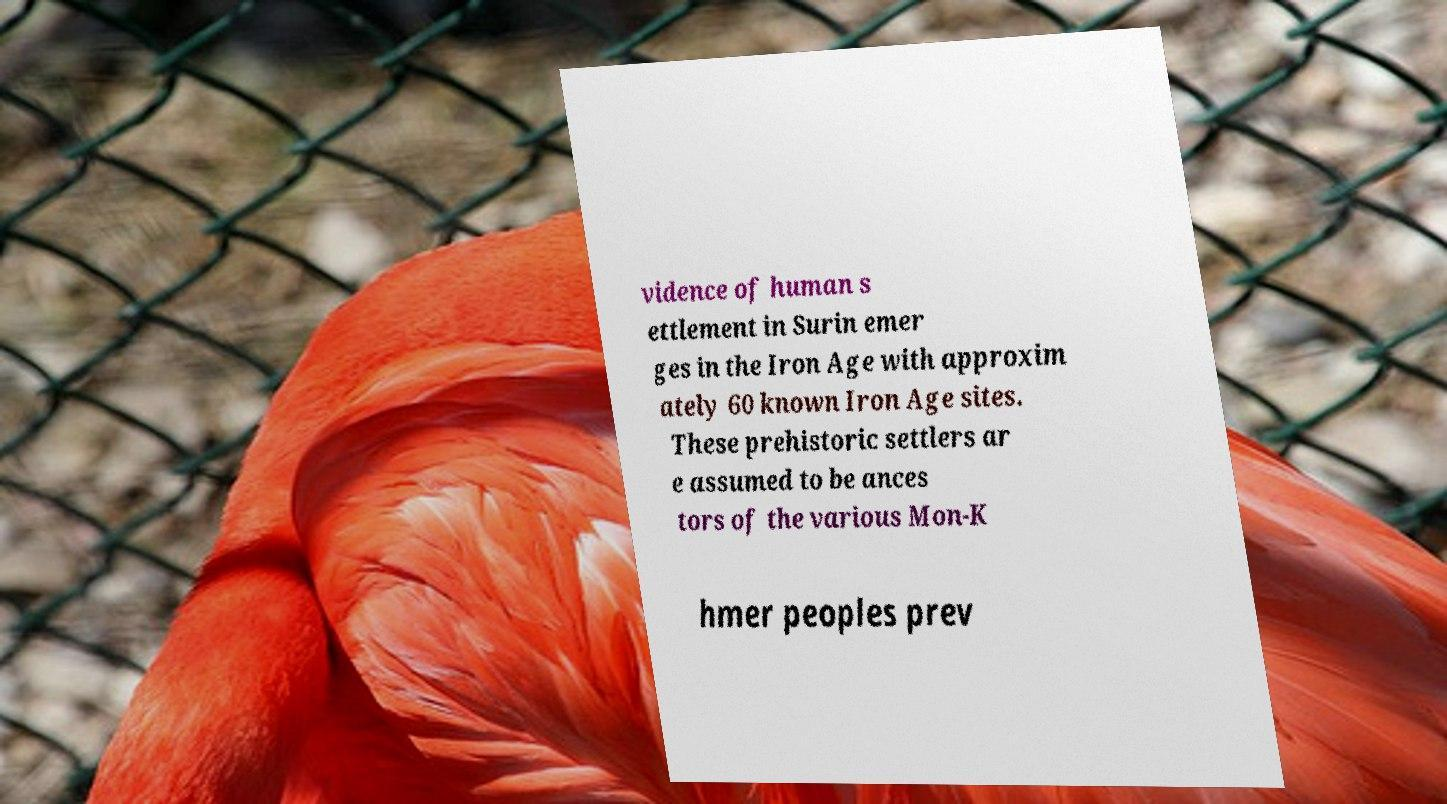For documentation purposes, I need the text within this image transcribed. Could you provide that? vidence of human s ettlement in Surin emer ges in the Iron Age with approxim ately 60 known Iron Age sites. These prehistoric settlers ar e assumed to be ances tors of the various Mon-K hmer peoples prev 